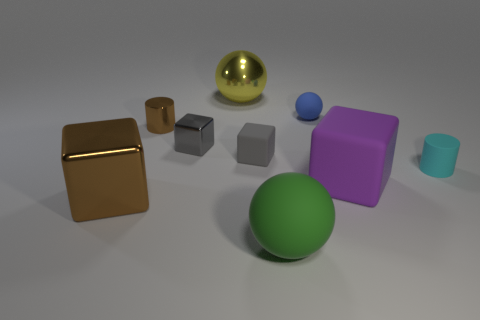There is a thing that is the same color as the tiny metallic cylinder; what material is it?
Offer a terse response. Metal. The small cylinder on the left side of the large matte thing right of the tiny blue matte object is made of what material?
Your answer should be very brief. Metal. What material is the thing that is both in front of the tiny cyan object and right of the tiny rubber ball?
Your answer should be very brief. Rubber. What is the size of the ball in front of the shiny thing that is in front of the tiny cube left of the big yellow sphere?
Make the answer very short. Large. Are there any other things that are the same size as the yellow shiny object?
Make the answer very short. Yes. What is the material of the large yellow thing that is the same shape as the blue thing?
Make the answer very short. Metal. Is there a blue thing that is in front of the large shiny object that is to the left of the brown shiny thing behind the cyan rubber cylinder?
Your response must be concise. No. Do the brown thing behind the big metallic block and the gray matte thing to the right of the gray metallic thing have the same shape?
Your response must be concise. No. Are there more metallic cubes that are on the left side of the tiny gray metallic thing than large cubes?
Ensure brevity in your answer.  No. How many things are small yellow metal balls or tiny cyan objects?
Your response must be concise. 1. 